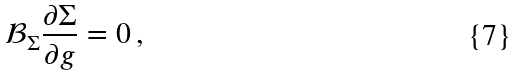<formula> <loc_0><loc_0><loc_500><loc_500>\mathcal { B } _ { \Sigma } \frac { \partial \Sigma } { \partial g } = 0 \, ,</formula> 